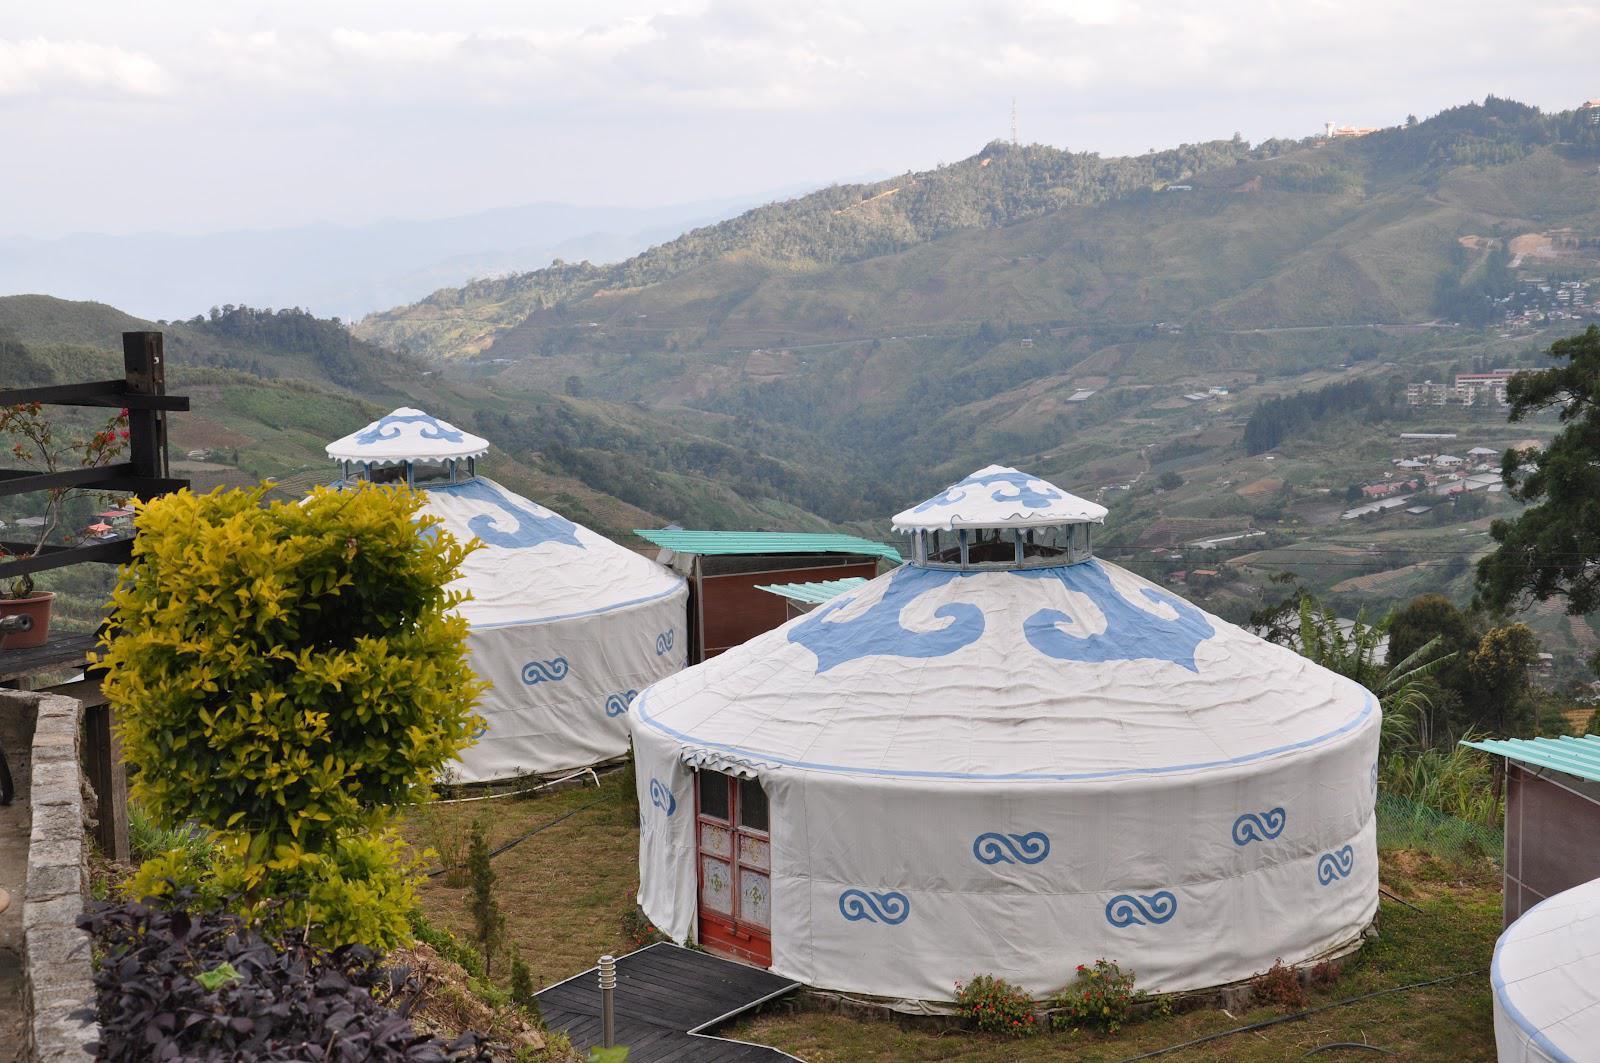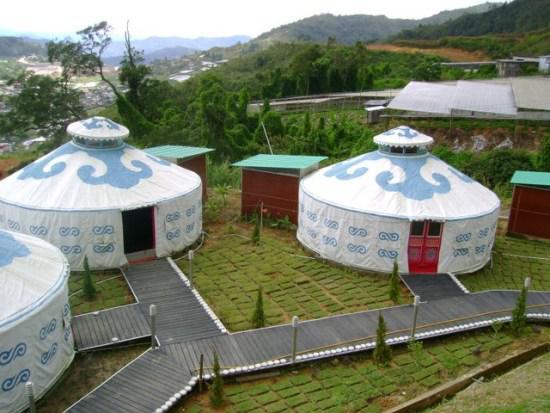The first image is the image on the left, the second image is the image on the right. Evaluate the accuracy of this statement regarding the images: "One interior image of a yurt shows a bedroom with one wide bed with a headboard and a trunk sitting at the end of the bed.". Is it true? Answer yes or no. No. 